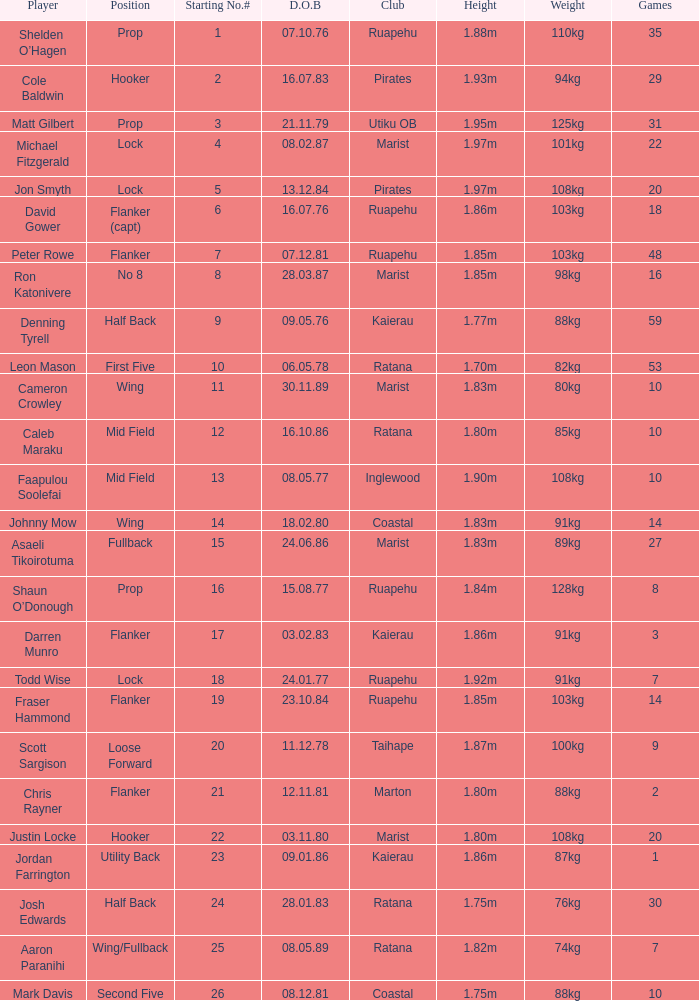What is the birthday for the player in the inglewood club? 80577.0. 